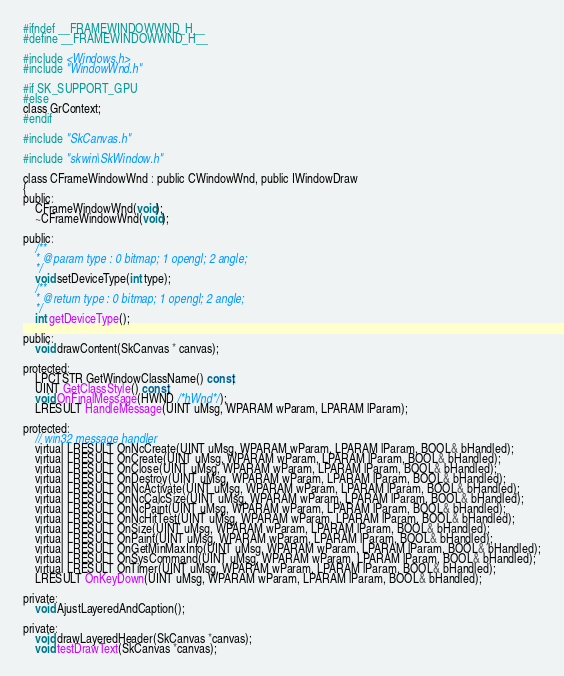Convert code to text. <code><loc_0><loc_0><loc_500><loc_500><_C_>#ifndef __FRAMEWINDOWWND_H__
#define __FRAMEWINDOWWND_H__

#include <Windows.h>
#include "WindowWnd.h"

#if SK_SUPPORT_GPU
#else
class GrContext;
#endif

#include "SkCanvas.h"

#include "skwin\SkWindow.h"

class CFrameWindowWnd : public CWindowWnd, public IWindowDraw
{
public:
	CFrameWindowWnd(void);
	~CFrameWindowWnd(void);

public:
	/**
	* @param type : 0 bitmap; 1 opengl; 2 angle;
	*/
	void setDeviceType(int type);
	/**
	* @return type : 0 bitmap; 1 opengl; 2 angle;
	*/
	int getDeviceType();

public:
	void drawContent(SkCanvas * canvas);

protected:
	LPCTSTR GetWindowClassName() const;
	UINT GetClassStyle() const;
	void OnFinalMessage(HWND /*hWnd*/);
	LRESULT HandleMessage(UINT uMsg, WPARAM wParam, LPARAM lParam);

protected:
	// win32 message handler
	virtual LRESULT OnNcCreate(UINT uMsg, WPARAM wParam, LPARAM lParam, BOOL& bHandled);
	virtual LRESULT OnCreate(UINT uMsg, WPARAM wParam, LPARAM lParam, BOOL& bHandled);
	virtual LRESULT OnClose(UINT uMsg, WPARAM wParam, LPARAM lParam, BOOL& bHandled);
	virtual LRESULT OnDestroy(UINT uMsg, WPARAM wParam, LPARAM lParam, BOOL& bHandled);
	virtual LRESULT OnNcActivate(UINT uMsg, WPARAM wParam, LPARAM lParam, BOOL& bHandled);
	virtual LRESULT OnNcCalcSize(UINT uMsg, WPARAM wParam, LPARAM lParam, BOOL& bHandled);
	virtual LRESULT OnNcPaint(UINT uMsg, WPARAM wParam, LPARAM lParam, BOOL& bHandled);
	virtual LRESULT OnNcHitTest(UINT uMsg, WPARAM wParam, LPARAM lParam, BOOL& bHandled);
	virtual LRESULT OnSize(UINT uMsg, WPARAM wParam, LPARAM lParam, BOOL& bHandled);
	virtual LRESULT OnPaint(UINT uMsg, WPARAM wParam, LPARAM lParam, BOOL& bHandled);
	virtual LRESULT OnGetMinMaxInfo(UINT uMsg, WPARAM wParam, LPARAM lParam, BOOL& bHandled);
	virtual LRESULT OnSysCommand(UINT uMsg, WPARAM wParam, LPARAM lParam, BOOL& bHandled);
	virtual LRESULT OnTimer(UINT uMsg, WPARAM wParam, LPARAM lParam, BOOL& bHandled);
	LRESULT OnKeyDown(UINT uMsg, WPARAM wParam, LPARAM lParam, BOOL& bHandled);

private:
	void AjustLayeredAndCaption();

private:
	void drawLayeredHeader(SkCanvas *canvas);
	void testDrawText(SkCanvas *canvas);</code> 